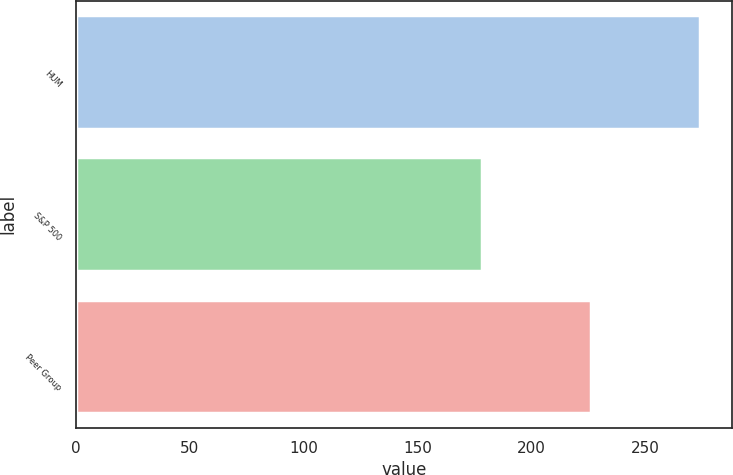Convert chart. <chart><loc_0><loc_0><loc_500><loc_500><bar_chart><fcel>HUM<fcel>S&P 500<fcel>Peer Group<nl><fcel>274<fcel>178<fcel>226<nl></chart> 